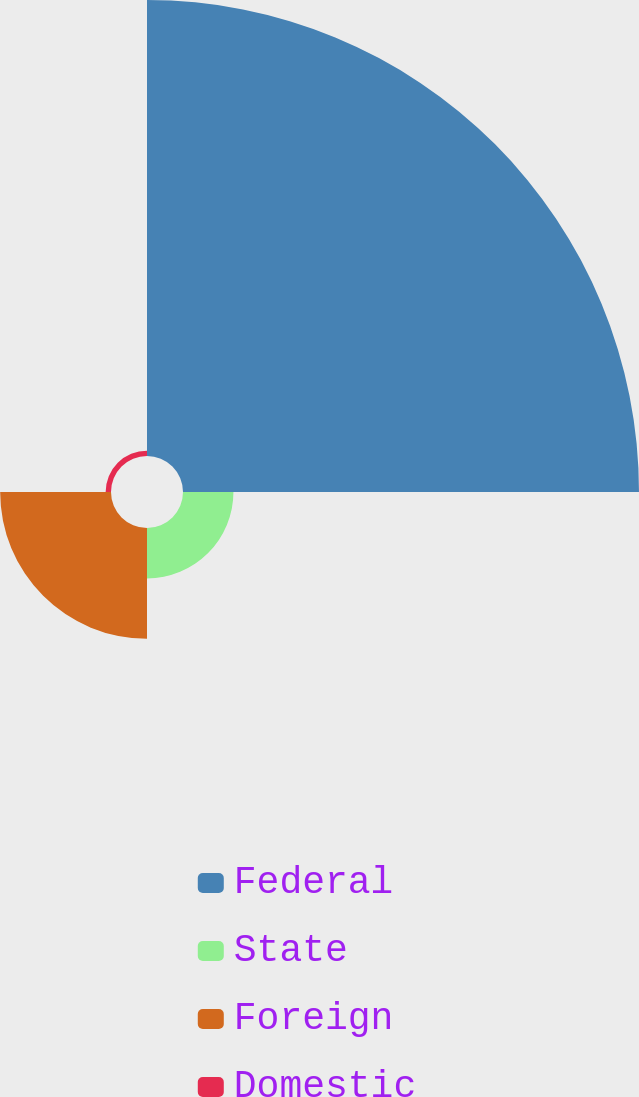Convert chart. <chart><loc_0><loc_0><loc_500><loc_500><pie_chart><fcel>Federal<fcel>State<fcel>Foreign<fcel>Domestic<nl><fcel>73.23%<fcel>8.1%<fcel>17.8%<fcel>0.86%<nl></chart> 